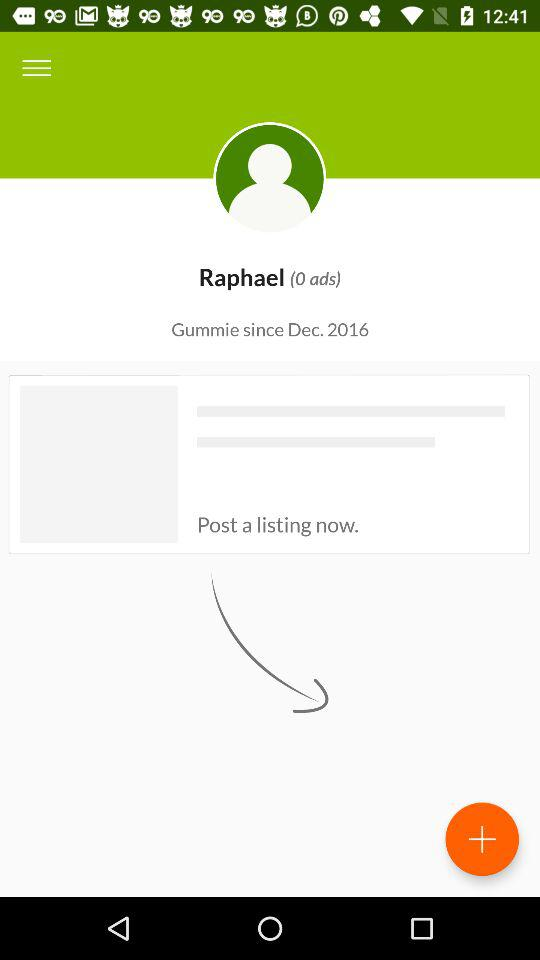When did Raphael last post a listing?
When the provided information is insufficient, respond with <no answer>. <no answer> 